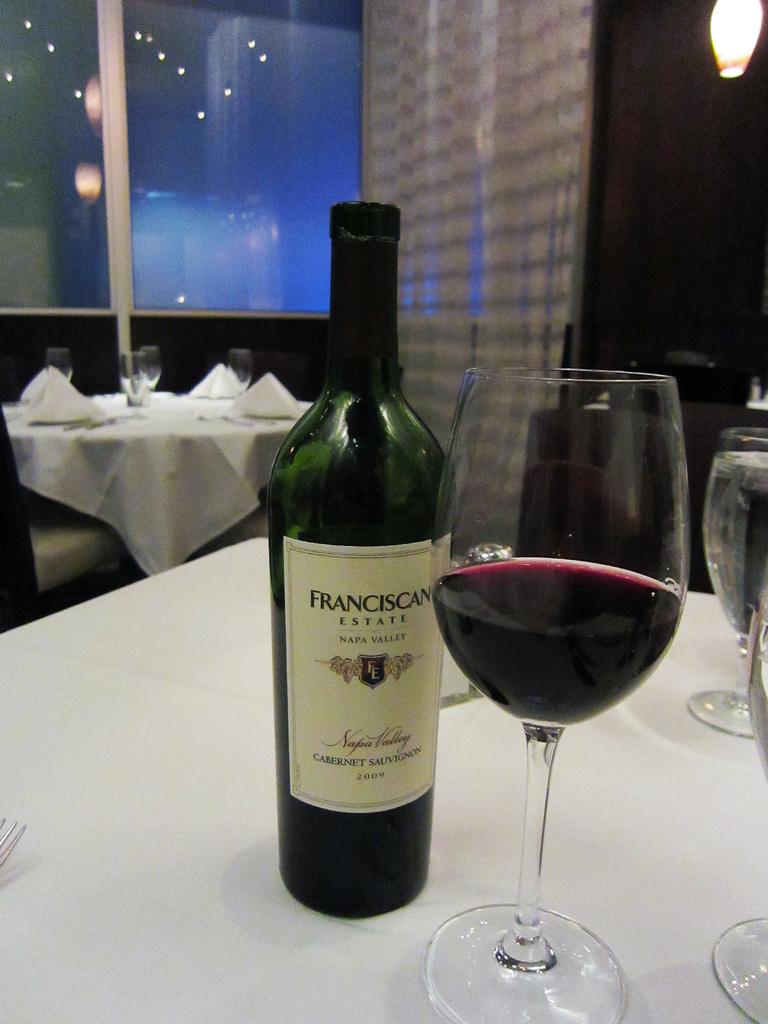Where does the label say the wine is from?
Your answer should be compact. Napa valley. 